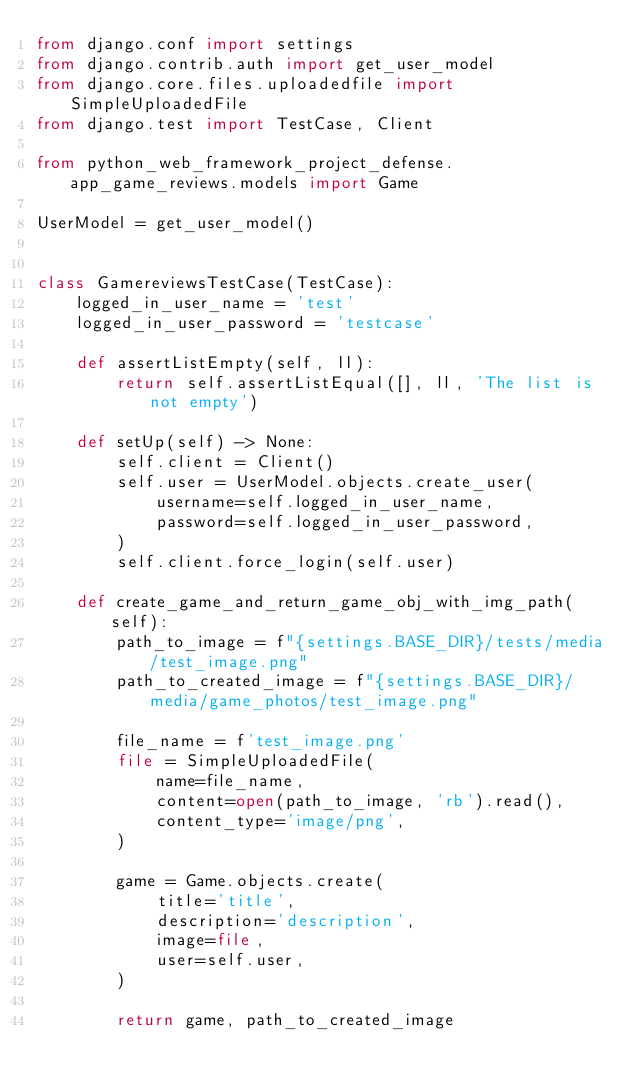Convert code to text. <code><loc_0><loc_0><loc_500><loc_500><_Python_>from django.conf import settings
from django.contrib.auth import get_user_model
from django.core.files.uploadedfile import SimpleUploadedFile
from django.test import TestCase, Client

from python_web_framework_project_defense.app_game_reviews.models import Game

UserModel = get_user_model()


class GamereviewsTestCase(TestCase):
    logged_in_user_name = 'test'
    logged_in_user_password = 'testcase'

    def assertListEmpty(self, ll):
        return self.assertListEqual([], ll, 'The list is not empty')

    def setUp(self) -> None:
        self.client = Client()
        self.user = UserModel.objects.create_user(
            username=self.logged_in_user_name,
            password=self.logged_in_user_password,
        )
        self.client.force_login(self.user)

    def create_game_and_return_game_obj_with_img_path(self):
        path_to_image = f"{settings.BASE_DIR}/tests/media/test_image.png"
        path_to_created_image = f"{settings.BASE_DIR}/media/game_photos/test_image.png"

        file_name = f'test_image.png'
        file = SimpleUploadedFile(
            name=file_name,
            content=open(path_to_image, 'rb').read(),
            content_type='image/png',
        )

        game = Game.objects.create(
            title='title',
            description='description',
            image=file,
            user=self.user,
        )

        return game, path_to_created_image
</code> 